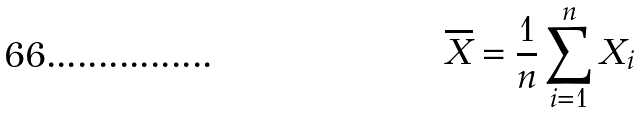<formula> <loc_0><loc_0><loc_500><loc_500>\overline { X } = \frac { 1 } { n } \sum _ { i = 1 } ^ { n } X _ { i }</formula> 